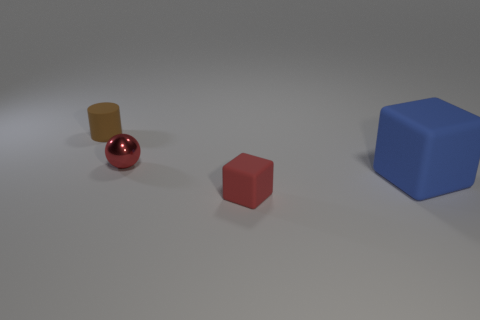There is a large object that is the same shape as the tiny red matte thing; what is its color? blue 